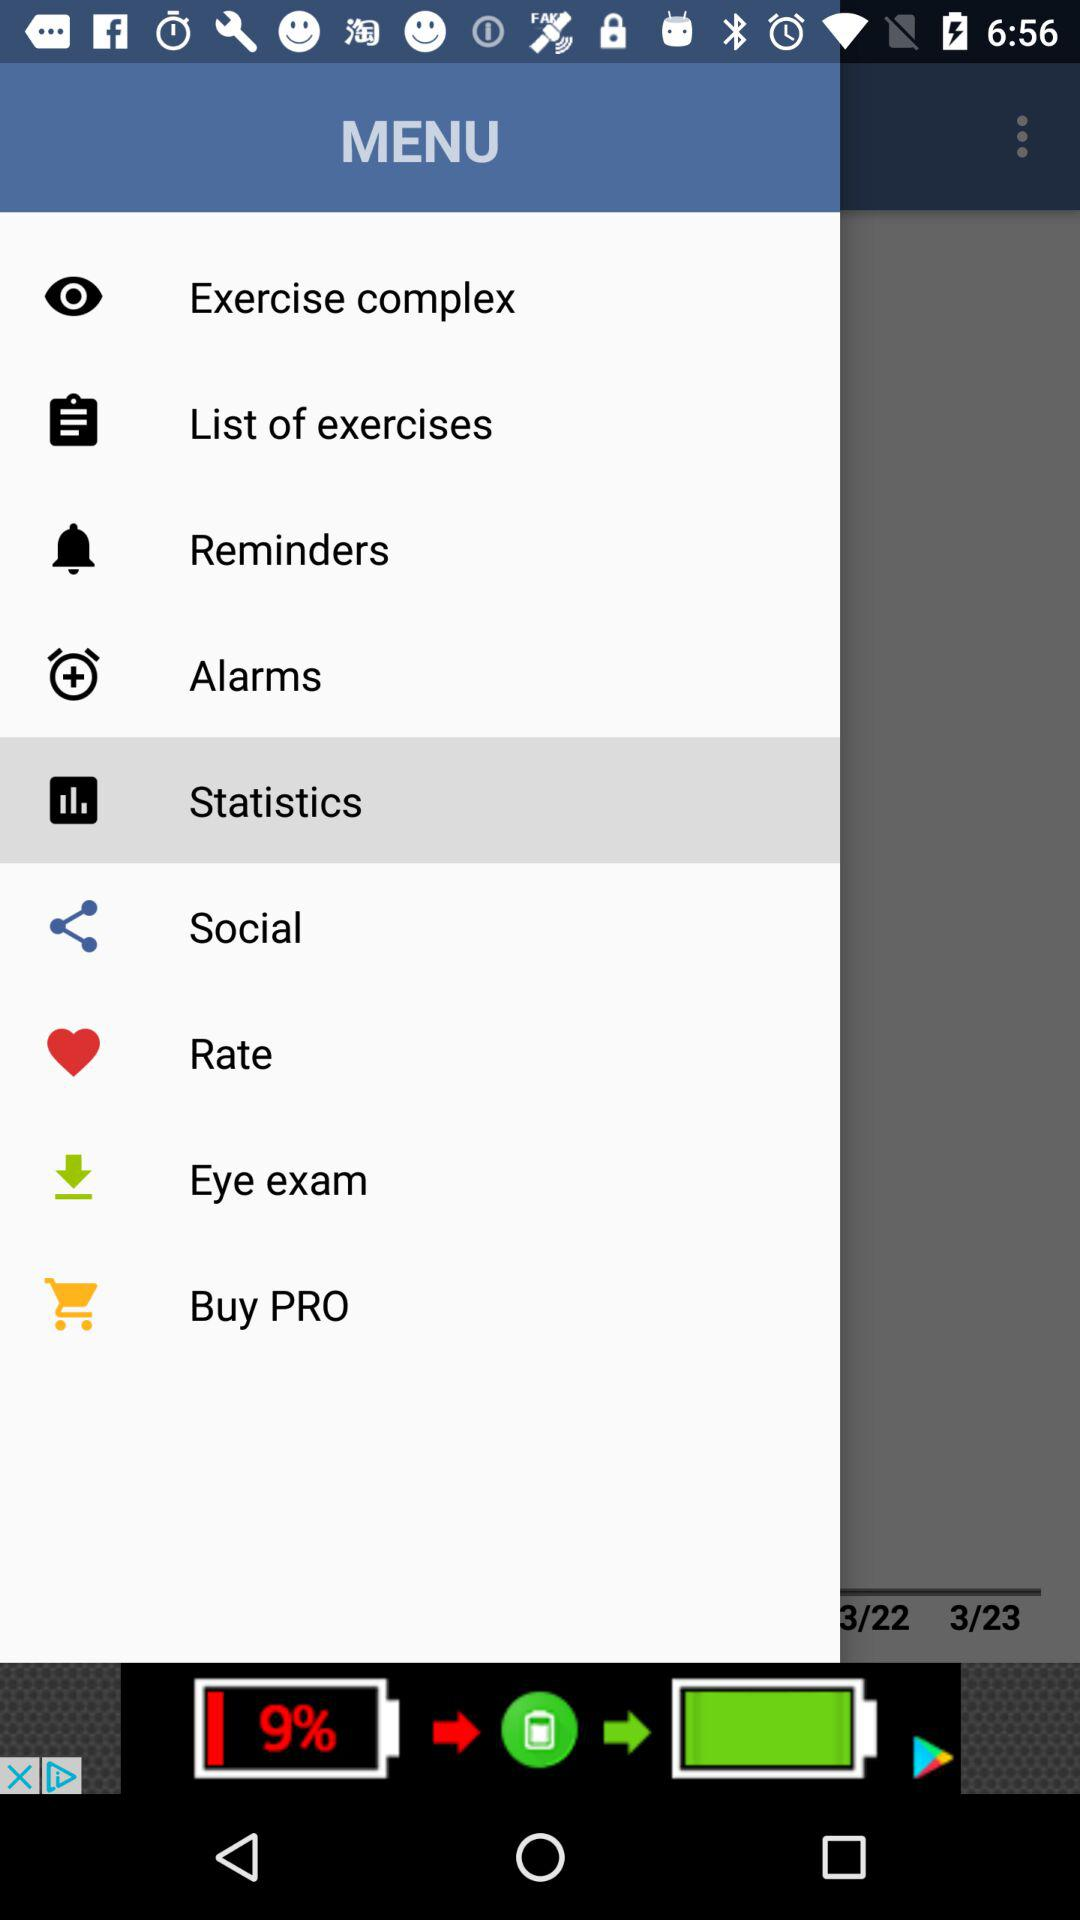Which item is currently selected in the menu? The currently selected item in the menu is "Statistics". 